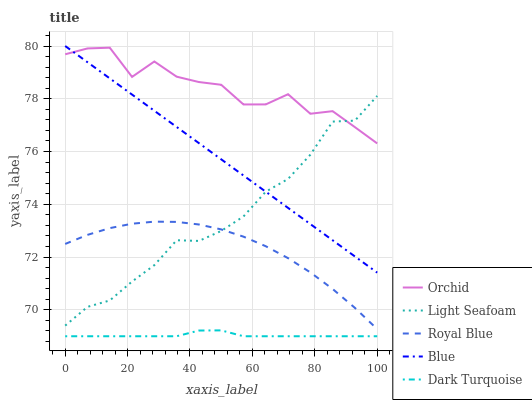Does Dark Turquoise have the minimum area under the curve?
Answer yes or no. Yes. Does Orchid have the maximum area under the curve?
Answer yes or no. Yes. Does Royal Blue have the minimum area under the curve?
Answer yes or no. No. Does Royal Blue have the maximum area under the curve?
Answer yes or no. No. Is Blue the smoothest?
Answer yes or no. Yes. Is Orchid the roughest?
Answer yes or no. Yes. Is Royal Blue the smoothest?
Answer yes or no. No. Is Royal Blue the roughest?
Answer yes or no. No. Does Dark Turquoise have the lowest value?
Answer yes or no. Yes. Does Royal Blue have the lowest value?
Answer yes or no. No. Does Blue have the highest value?
Answer yes or no. Yes. Does Royal Blue have the highest value?
Answer yes or no. No. Is Dark Turquoise less than Light Seafoam?
Answer yes or no. Yes. Is Blue greater than Dark Turquoise?
Answer yes or no. Yes. Does Light Seafoam intersect Royal Blue?
Answer yes or no. Yes. Is Light Seafoam less than Royal Blue?
Answer yes or no. No. Is Light Seafoam greater than Royal Blue?
Answer yes or no. No. Does Dark Turquoise intersect Light Seafoam?
Answer yes or no. No. 